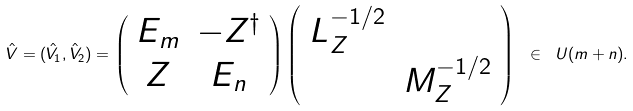<formula> <loc_0><loc_0><loc_500><loc_500>\hat { V } = ( \hat { V } _ { 1 } , \hat { V } _ { 2 } ) = \left ( \begin{array} { c c } E _ { m } & - Z ^ { \dagger } \\ Z & E _ { n } \end{array} \right ) \left ( \begin{array} { c c } L _ { Z } ^ { - 1 / 2 } & \\ & M _ { Z } ^ { - 1 / 2 } \end{array} \right ) \ \in \ U ( m + n ) .</formula> 